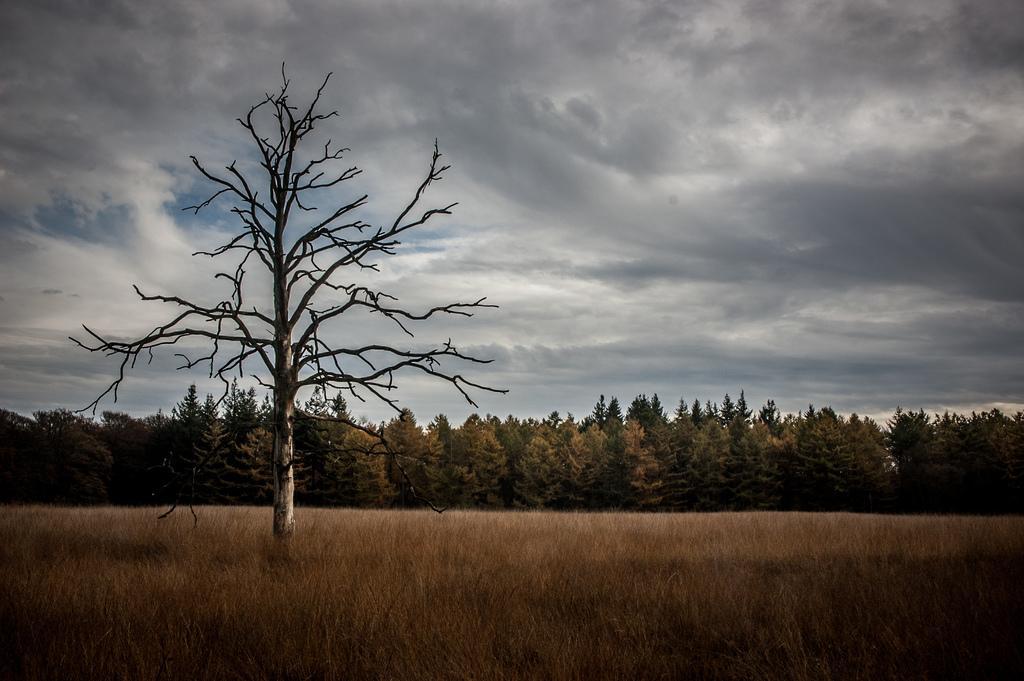In one or two sentences, can you explain what this image depicts? In this picture I can see trees and grass on the ground and a tree without leaves on the left side of the picture and a cloudy Sky. 